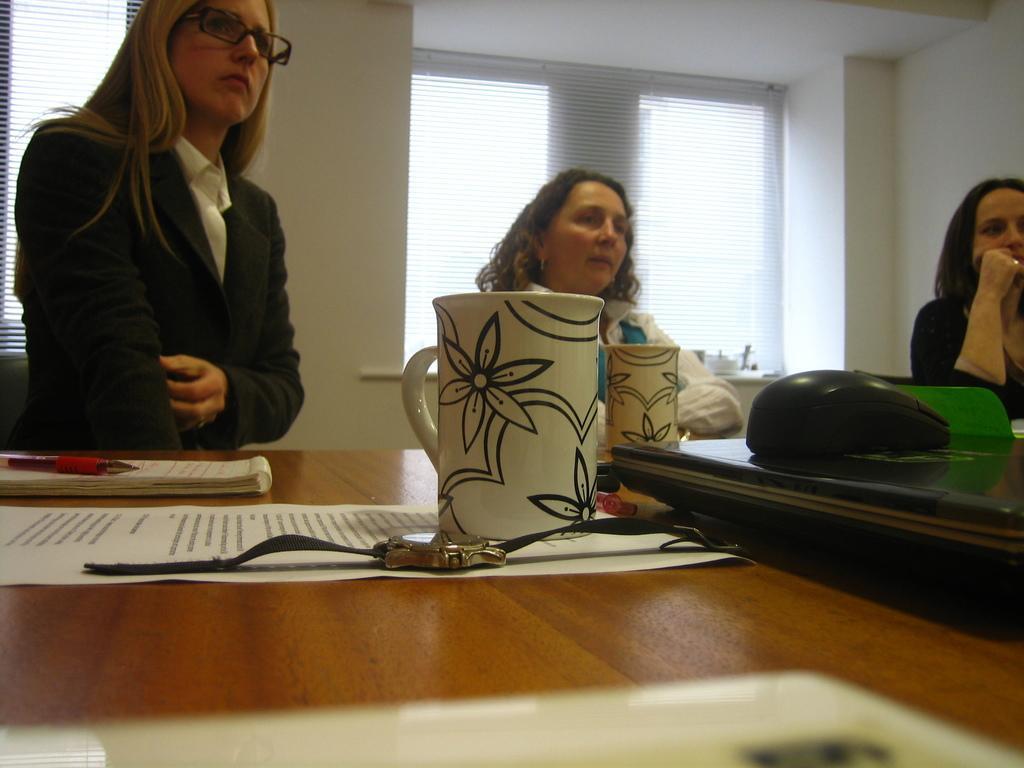Describe this image in one or two sentences. In the image we can see three persons are sitting on the chair around the table. On table,there is a mug,watch,paper,book,pen and tab. In the background we can see wall and window. 